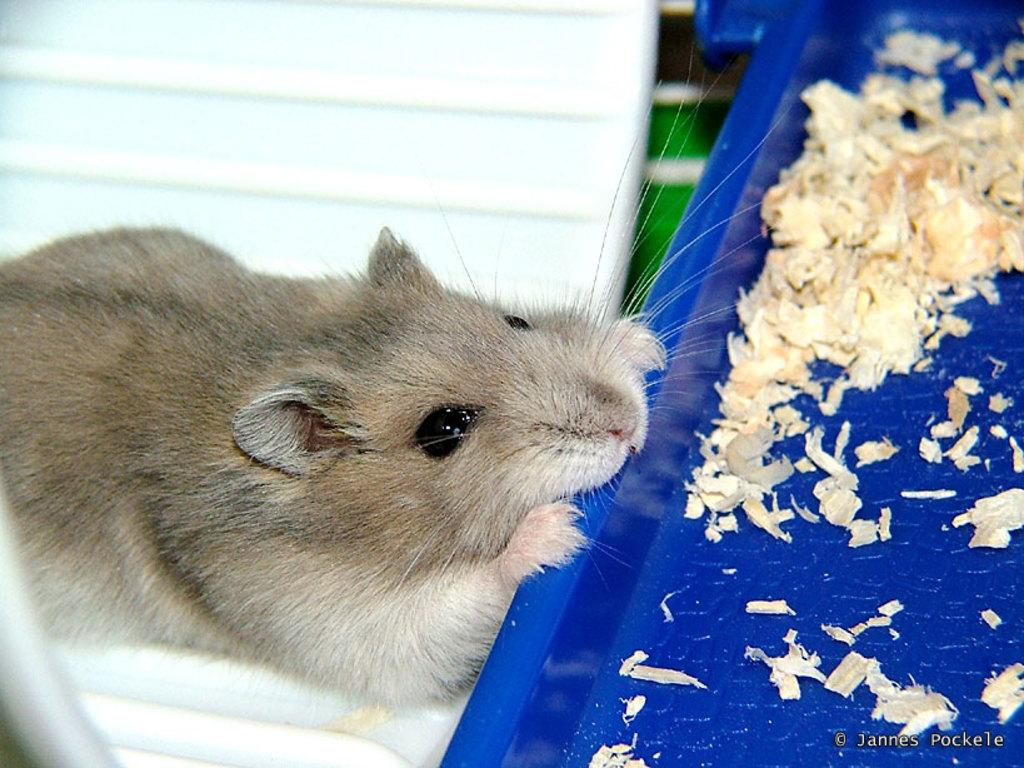What type of animal is in the image? There is a mouse in the image. What color is the mouse? The mouse is brown in color. What object is present in the image that is not the mouse? There is a blue color tray in the image. What is the purpose of the tray in the image? The tray contains food places. What color is the background of the image? The background of the image is pale blue in color. How many hairs can be seen on the mouse's head in the image? There is no indication of hair on the mouse's head in the image, as mice have fur and not hair. What type of fruit is being served on the tray in the image? There is no fruit visible on the tray in the image; it contains food places. 